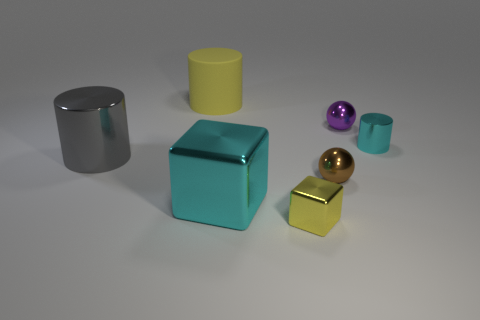What color is the small thing that is to the left of the small brown shiny ball?
Make the answer very short. Yellow. What size is the cyan cylinder?
Your response must be concise. Small. There is a matte thing; does it have the same color as the tiny metal sphere in front of the small cyan metal object?
Your answer should be compact. No. What color is the metallic block behind the yellow thing on the right side of the large cyan cube?
Your answer should be very brief. Cyan. Is there any other thing that is the same size as the cyan cylinder?
Offer a very short reply. Yes. Do the cyan thing that is to the left of the small purple object and the small brown object have the same shape?
Offer a very short reply. No. How many things are on the right side of the large cyan thing and on the left side of the purple sphere?
Offer a very short reply. 2. What color is the big object that is in front of the object that is to the left of the large object behind the tiny cyan metallic cylinder?
Give a very brief answer. Cyan. There is a yellow thing that is in front of the gray cylinder; how many yellow cylinders are on the right side of it?
Your response must be concise. 0. What number of other things are the same shape as the big cyan metal thing?
Your answer should be very brief. 1. 